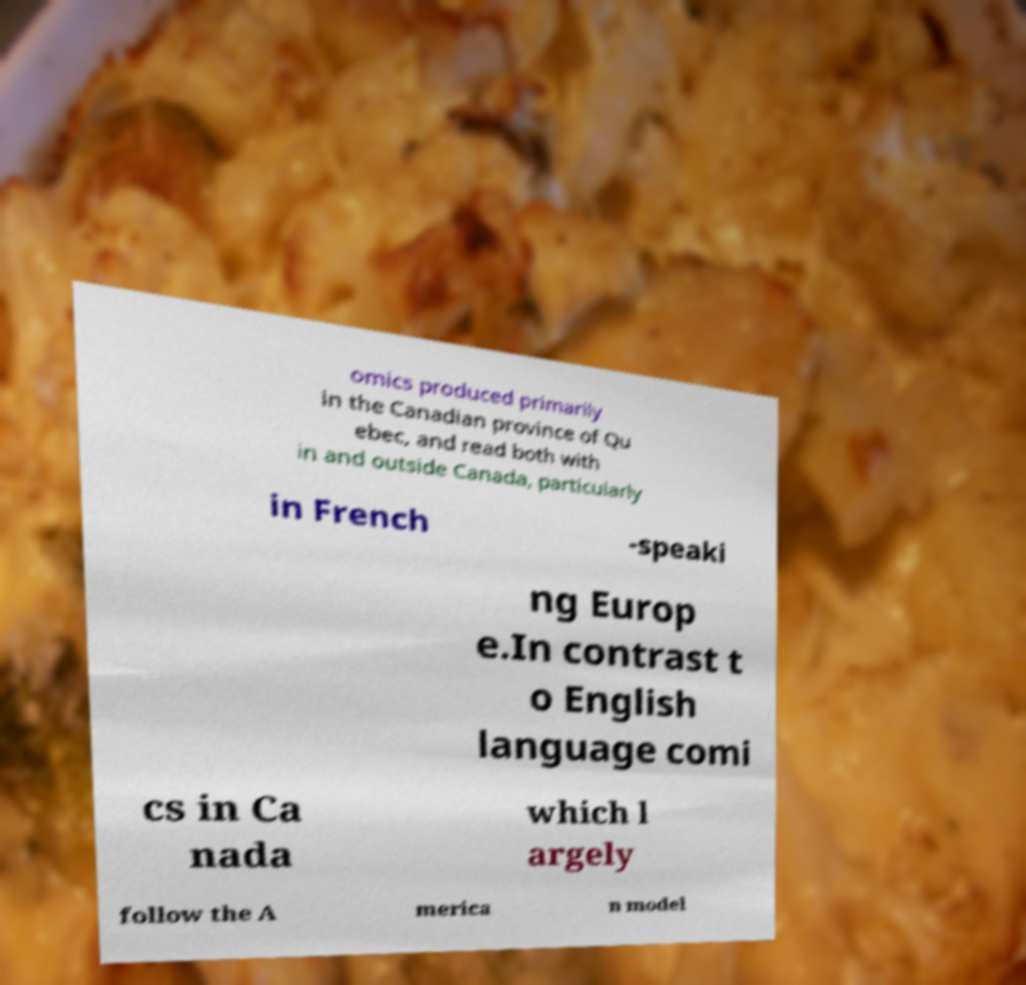Please identify and transcribe the text found in this image. omics produced primarily in the Canadian province of Qu ebec, and read both with in and outside Canada, particularly in French -speaki ng Europ e.In contrast t o English language comi cs in Ca nada which l argely follow the A merica n model 